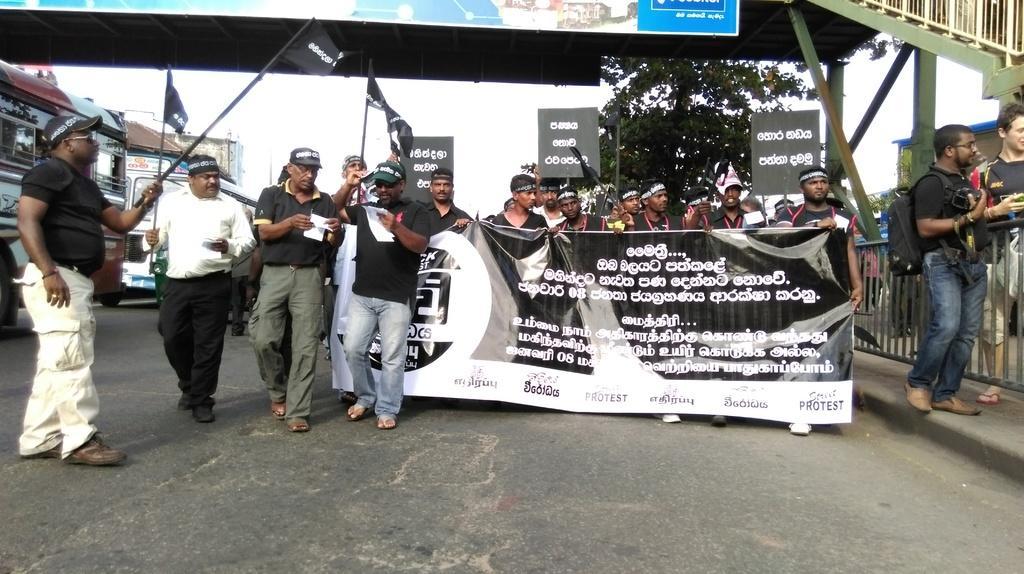Describe this image in one or two sentences. In the picture I can see some people are walking on the road and they are holding, boards, beside we can see some vehicles are moving on the road. 